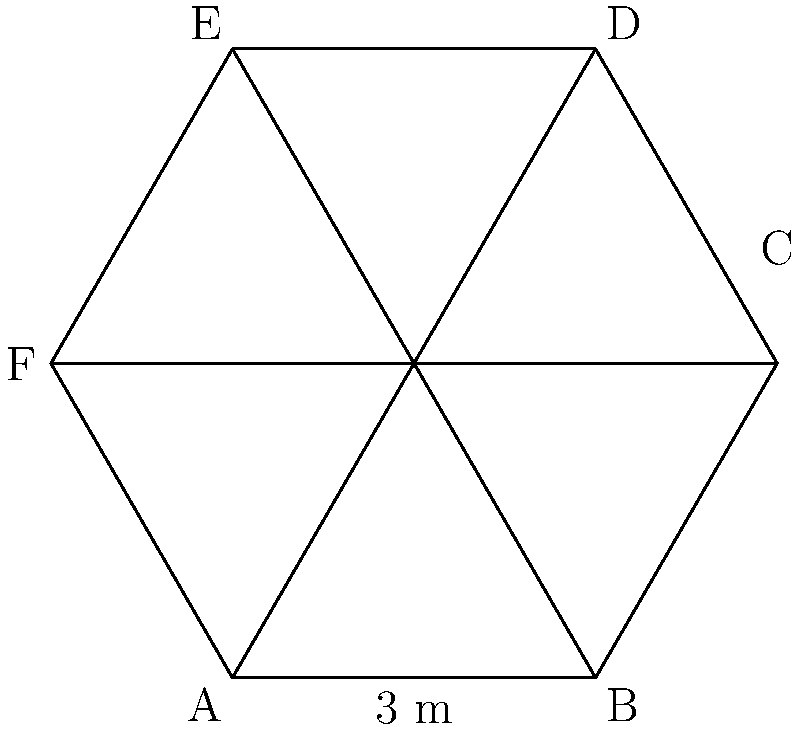As a HR manager, you're tasked with designing a hexagonal conference table for a new meeting room. The table should comfortably seat six executives while maintaining a professional appearance. If one side of the hexagon measures 3 meters, what is the total area of the table? Round your answer to the nearest square meter. Let's approach this step-by-step:

1) In a regular hexagon, all sides are equal and all interior angles are 120°.

2) We can divide the hexagon into six equilateral triangles.

3) For each equilateral triangle:
   - The base is 3 meters (given)
   - To find the height, we use the 30-60-90 triangle formula:
     Height = $\frac{\sqrt{3}}{2} \times$ base
     Height = $\frac{\sqrt{3}}{2} \times 3 = \frac{3\sqrt{3}}{2}$ meters

4) The area of one equilateral triangle is:
   $A_{triangle} = \frac{1}{2} \times$ base $\times$ height
   $A_{triangle} = \frac{1}{2} \times 3 \times \frac{3\sqrt{3}}{2} = \frac{9\sqrt{3}}{4}$ square meters

5) The total area of the hexagon is six times the area of one triangle:
   $A_{hexagon} = 6 \times \frac{9\sqrt{3}}{4} = \frac{27\sqrt{3}}{2}$ square meters

6) Calculate the value:
   $\frac{27\sqrt{3}}{2} \approx 23.38$ square meters

7) Rounding to the nearest square meter: 23 square meters

This size ensures ample space for six executives while maintaining a professional and practical design for the conference room.
Answer: 23 square meters 